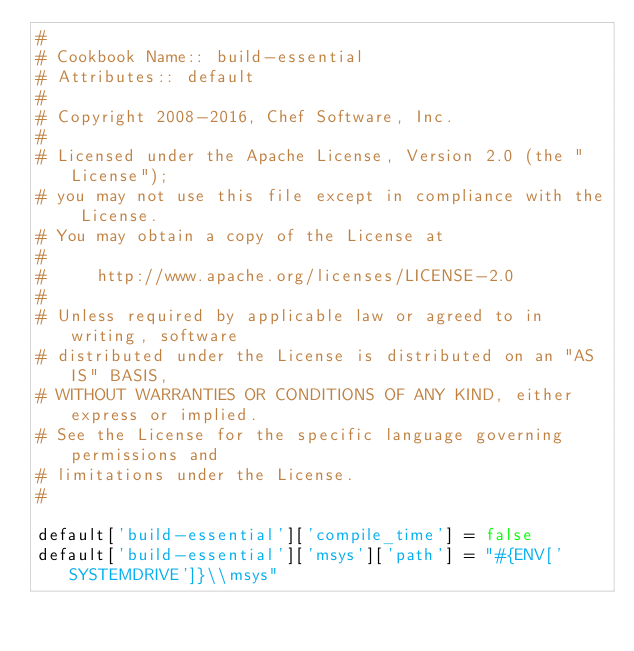Convert code to text. <code><loc_0><loc_0><loc_500><loc_500><_Ruby_>#
# Cookbook Name:: build-essential
# Attributes:: default
#
# Copyright 2008-2016, Chef Software, Inc.
#
# Licensed under the Apache License, Version 2.0 (the "License");
# you may not use this file except in compliance with the License.
# You may obtain a copy of the License at
#
#     http://www.apache.org/licenses/LICENSE-2.0
#
# Unless required by applicable law or agreed to in writing, software
# distributed under the License is distributed on an "AS IS" BASIS,
# WITHOUT WARRANTIES OR CONDITIONS OF ANY KIND, either express or implied.
# See the License for the specific language governing permissions and
# limitations under the License.
#

default['build-essential']['compile_time'] = false
default['build-essential']['msys']['path'] = "#{ENV['SYSTEMDRIVE']}\\msys"
</code> 